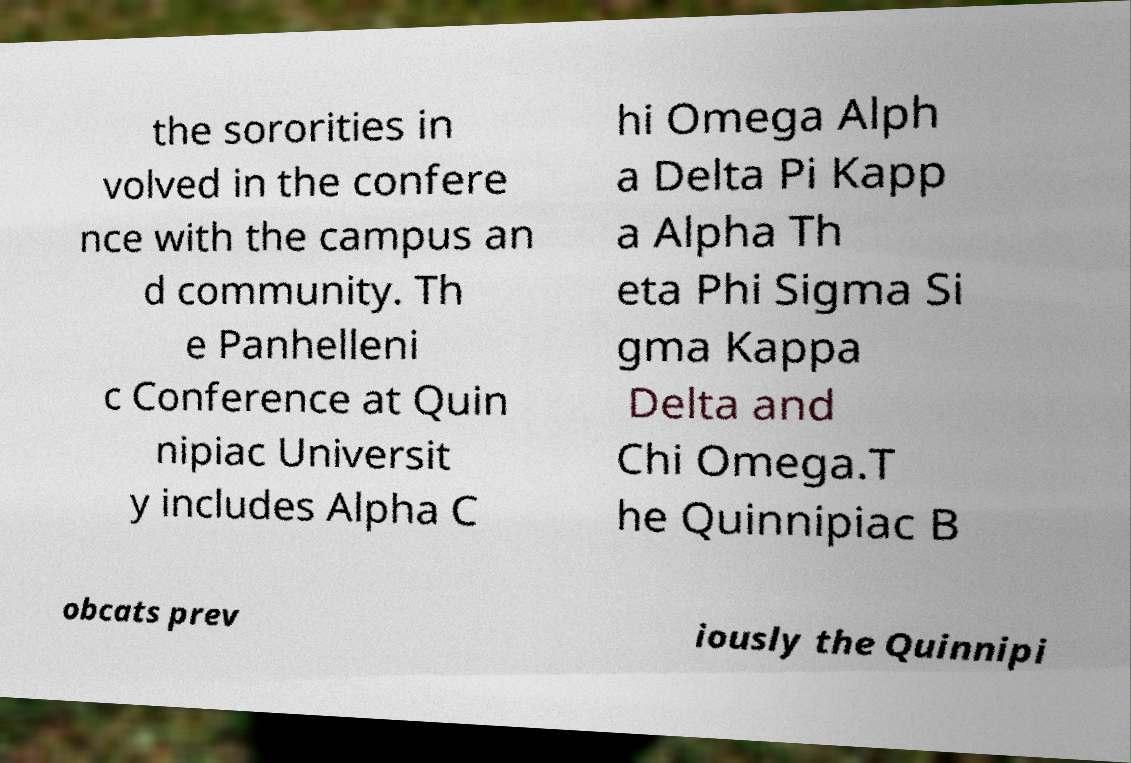Can you read and provide the text displayed in the image?This photo seems to have some interesting text. Can you extract and type it out for me? the sororities in volved in the confere nce with the campus an d community. Th e Panhelleni c Conference at Quin nipiac Universit y includes Alpha C hi Omega Alph a Delta Pi Kapp a Alpha Th eta Phi Sigma Si gma Kappa Delta and Chi Omega.T he Quinnipiac B obcats prev iously the Quinnipi 